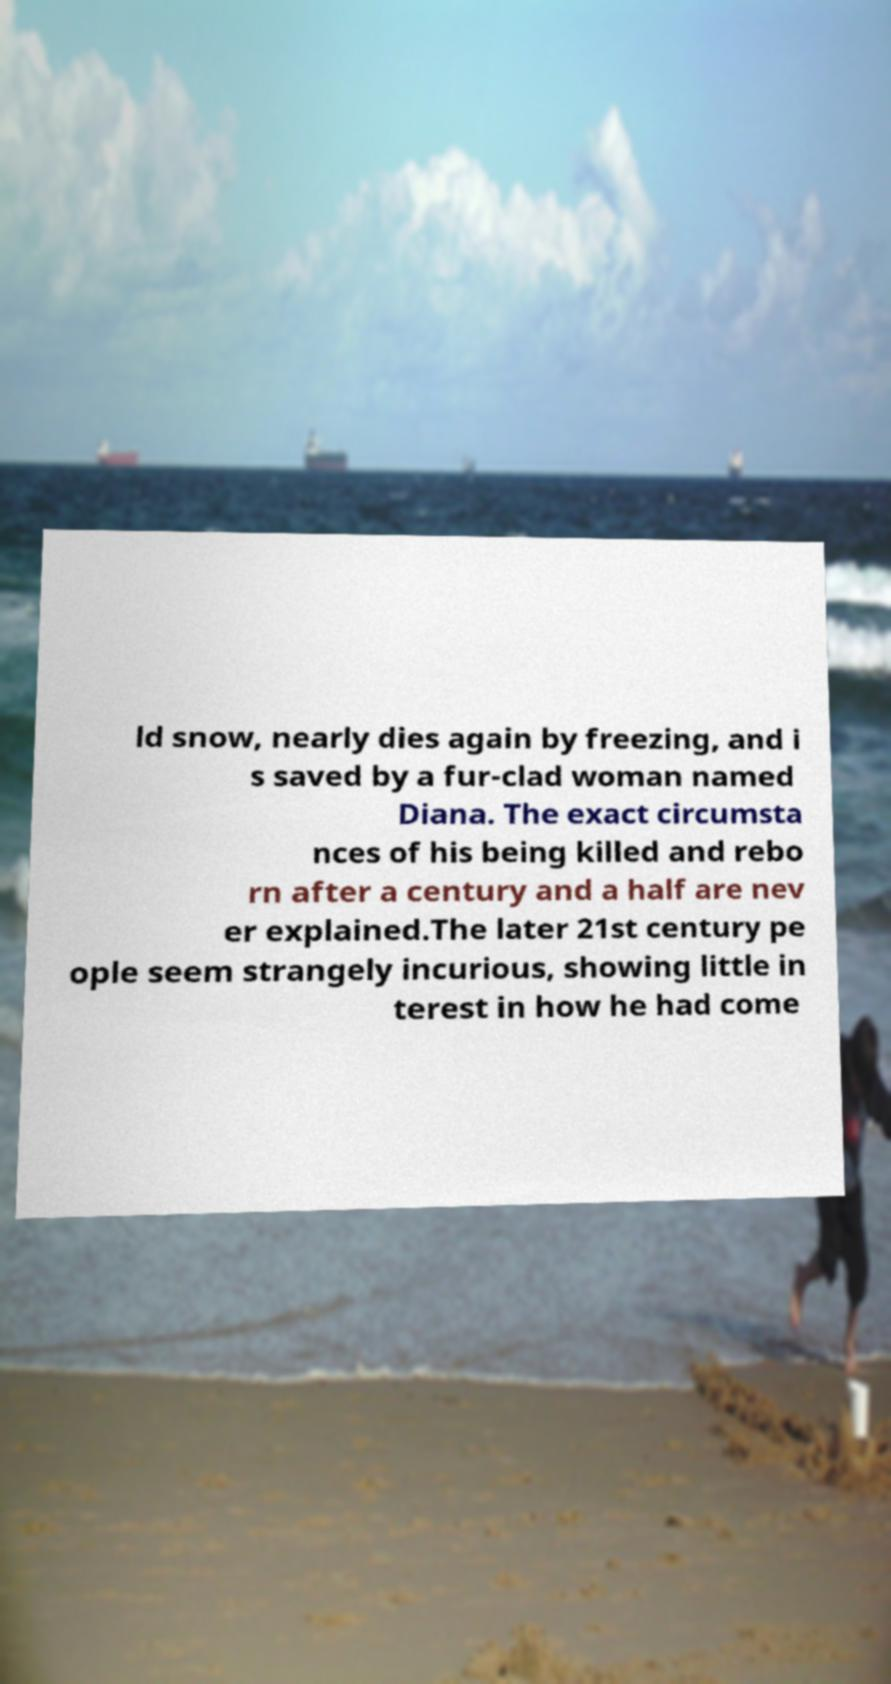Could you assist in decoding the text presented in this image and type it out clearly? ld snow, nearly dies again by freezing, and i s saved by a fur-clad woman named Diana. The exact circumsta nces of his being killed and rebo rn after a century and a half are nev er explained.The later 21st century pe ople seem strangely incurious, showing little in terest in how he had come 